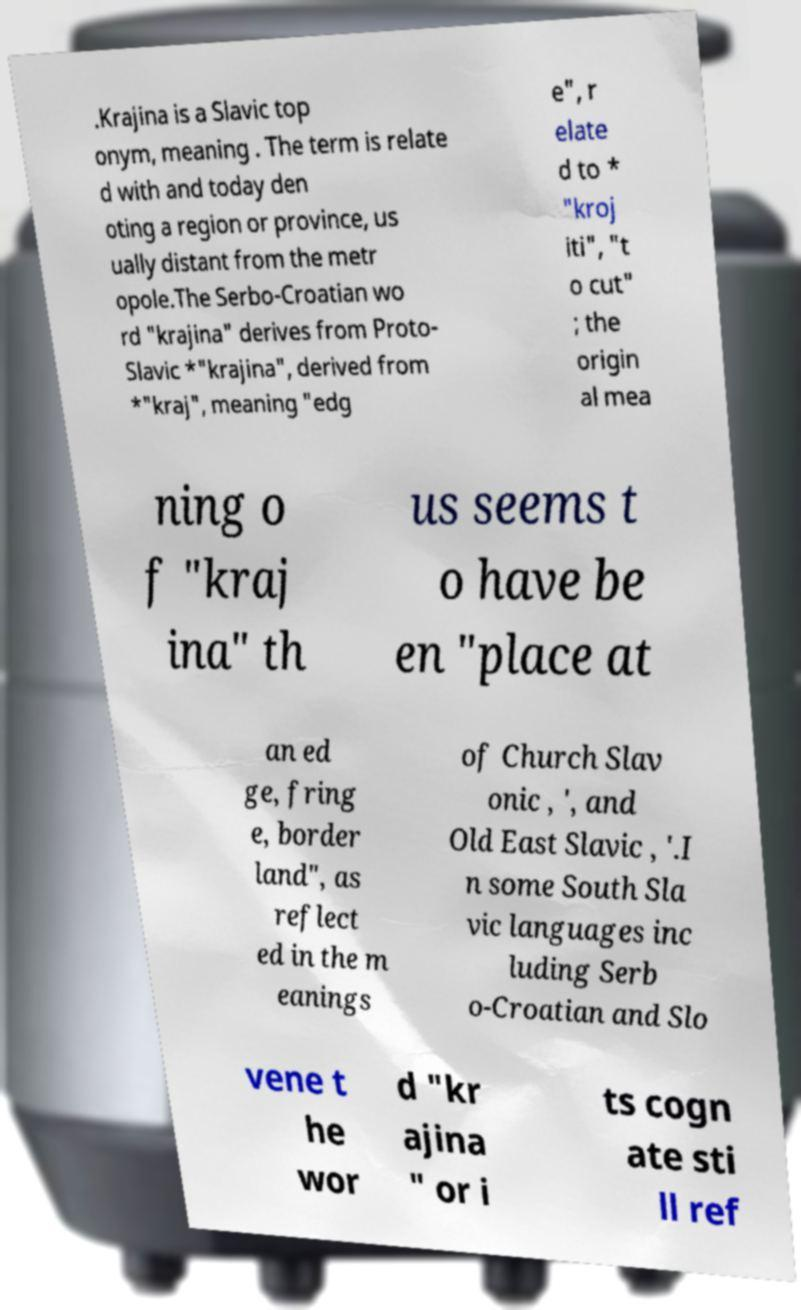Could you assist in decoding the text presented in this image and type it out clearly? .Krajina is a Slavic top onym, meaning . The term is relate d with and today den oting a region or province, us ually distant from the metr opole.The Serbo-Croatian wo rd "krajina" derives from Proto- Slavic *"krajina", derived from *"kraj", meaning "edg e", r elate d to * "kroj iti", "t o cut" ; the origin al mea ning o f "kraj ina" th us seems t o have be en "place at an ed ge, fring e, border land", as reflect ed in the m eanings of Church Slav onic , ', and Old East Slavic , '.I n some South Sla vic languages inc luding Serb o-Croatian and Slo vene t he wor d "kr ajina " or i ts cogn ate sti ll ref 